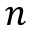Convert formula to latex. <formula><loc_0><loc_0><loc_500><loc_500>n</formula> 